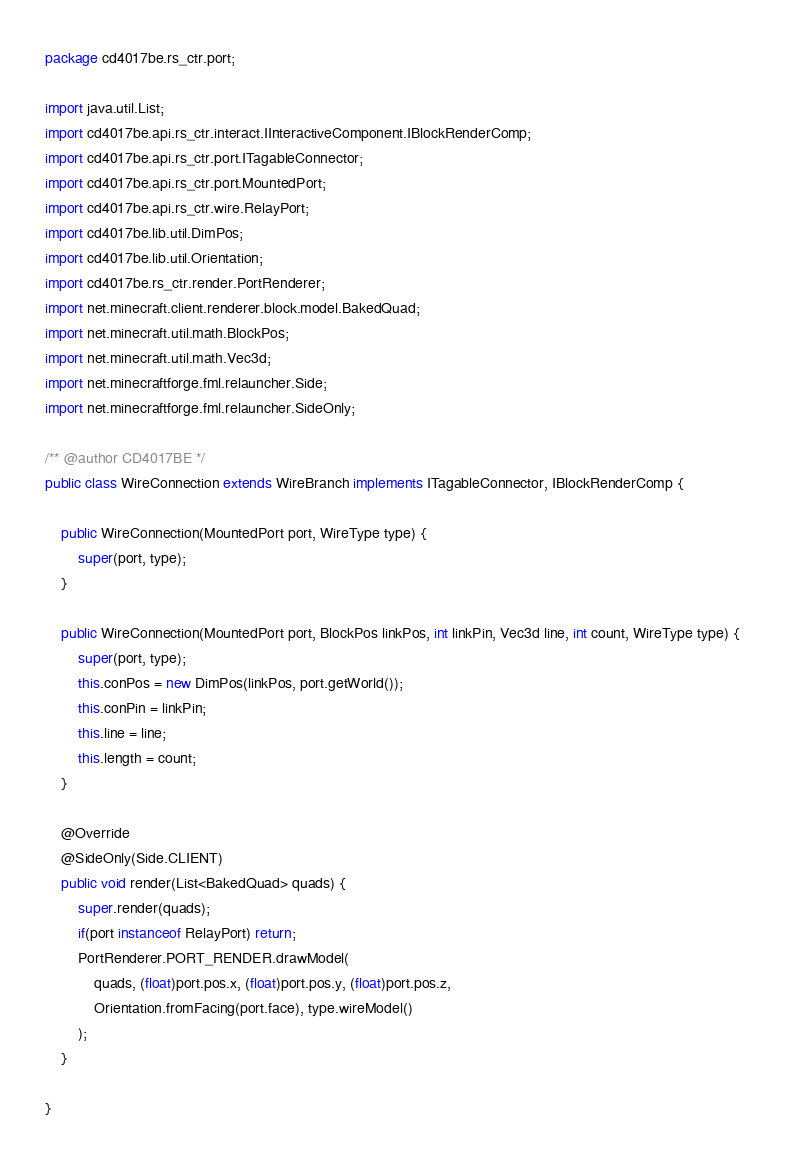Convert code to text. <code><loc_0><loc_0><loc_500><loc_500><_Java_>package cd4017be.rs_ctr.port;

import java.util.List;
import cd4017be.api.rs_ctr.interact.IInteractiveComponent.IBlockRenderComp;
import cd4017be.api.rs_ctr.port.ITagableConnector;
import cd4017be.api.rs_ctr.port.MountedPort;
import cd4017be.api.rs_ctr.wire.RelayPort;
import cd4017be.lib.util.DimPos;
import cd4017be.lib.util.Orientation;
import cd4017be.rs_ctr.render.PortRenderer;
import net.minecraft.client.renderer.block.model.BakedQuad;
import net.minecraft.util.math.BlockPos;
import net.minecraft.util.math.Vec3d;
import net.minecraftforge.fml.relauncher.Side;
import net.minecraftforge.fml.relauncher.SideOnly;

/** @author CD4017BE */
public class WireConnection extends WireBranch implements ITagableConnector, IBlockRenderComp {

	public WireConnection(MountedPort port, WireType type) {
		super(port, type);
	}

	public WireConnection(MountedPort port, BlockPos linkPos, int linkPin, Vec3d line, int count, WireType type) {
		super(port, type);
		this.conPos = new DimPos(linkPos, port.getWorld());
		this.conPin = linkPin;
		this.line = line;
		this.length = count;
	}

	@Override
	@SideOnly(Side.CLIENT)
	public void render(List<BakedQuad> quads) {
		super.render(quads);
		if(port instanceof RelayPort) return;
		PortRenderer.PORT_RENDER.drawModel(
			quads, (float)port.pos.x, (float)port.pos.y, (float)port.pos.z,
			Orientation.fromFacing(port.face), type.wireModel()
		);
	}

}
</code> 